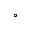<formula> <loc_0><loc_0><loc_500><loc_500>^ { \circ }</formula> 